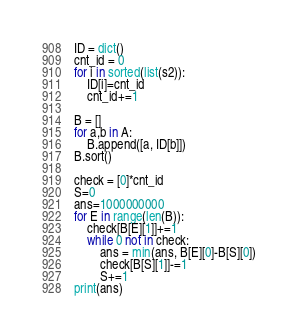<code> <loc_0><loc_0><loc_500><loc_500><_Python_>ID = dict()
cnt_id = 0
for i in sorted(list(s2)):
	ID[i]=cnt_id
	cnt_id+=1

B = []
for a,b in A:
	B.append([a, ID[b]])
B.sort()

check = [0]*cnt_id
S=0
ans=1000000000
for E in range(len(B)):
	check[B[E][1]]+=1
	while 0 not in check:
		ans = min(ans, B[E][0]-B[S][0])
		check[B[S][1]]-=1
		S+=1
print(ans)
</code> 